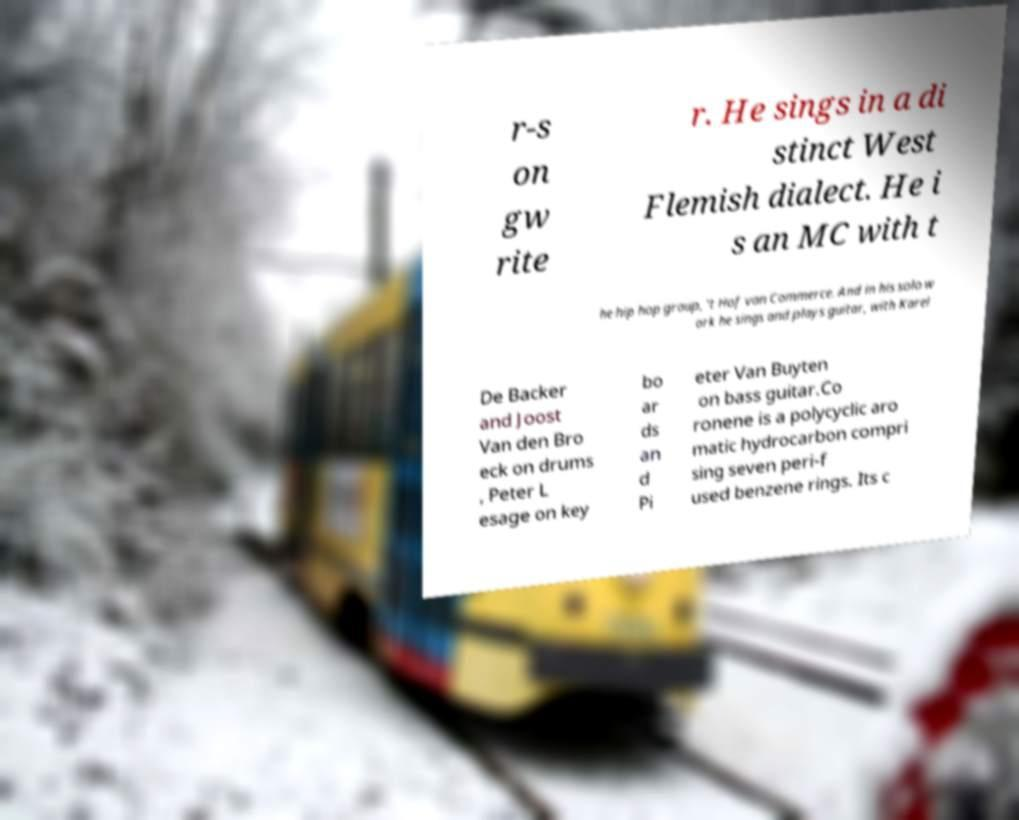Can you read and provide the text displayed in the image?This photo seems to have some interesting text. Can you extract and type it out for me? r-s on gw rite r. He sings in a di stinct West Flemish dialect. He i s an MC with t he hip hop group, 't Hof van Commerce. And in his solo w ork he sings and plays guitar, with Karel De Backer and Joost Van den Bro eck on drums , Peter L esage on key bo ar ds an d Pi eter Van Buyten on bass guitar.Co ronene is a polycyclic aro matic hydrocarbon compri sing seven peri-f used benzene rings. Its c 